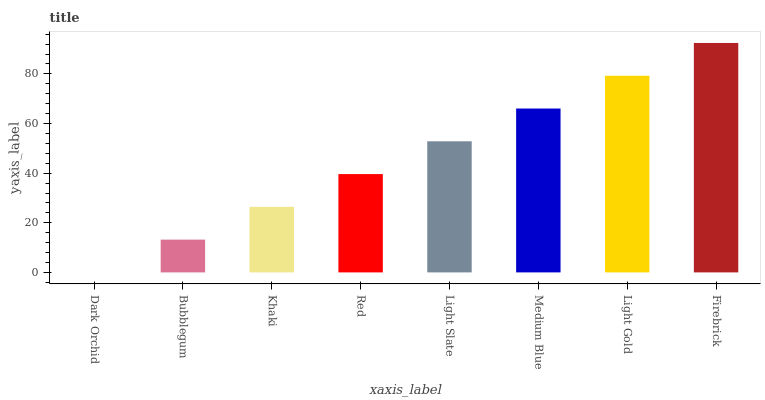Is Dark Orchid the minimum?
Answer yes or no. Yes. Is Firebrick the maximum?
Answer yes or no. Yes. Is Bubblegum the minimum?
Answer yes or no. No. Is Bubblegum the maximum?
Answer yes or no. No. Is Bubblegum greater than Dark Orchid?
Answer yes or no. Yes. Is Dark Orchid less than Bubblegum?
Answer yes or no. Yes. Is Dark Orchid greater than Bubblegum?
Answer yes or no. No. Is Bubblegum less than Dark Orchid?
Answer yes or no. No. Is Light Slate the high median?
Answer yes or no. Yes. Is Red the low median?
Answer yes or no. Yes. Is Red the high median?
Answer yes or no. No. Is Light Gold the low median?
Answer yes or no. No. 